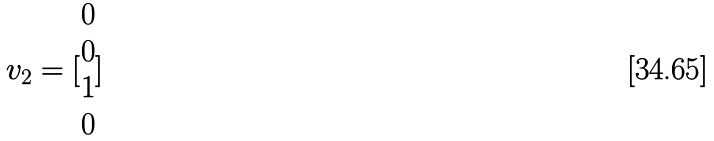<formula> <loc_0><loc_0><loc_500><loc_500>v _ { 2 } = [ \begin{matrix} 0 \\ 0 \\ 1 \\ 0 \end{matrix} ]</formula> 